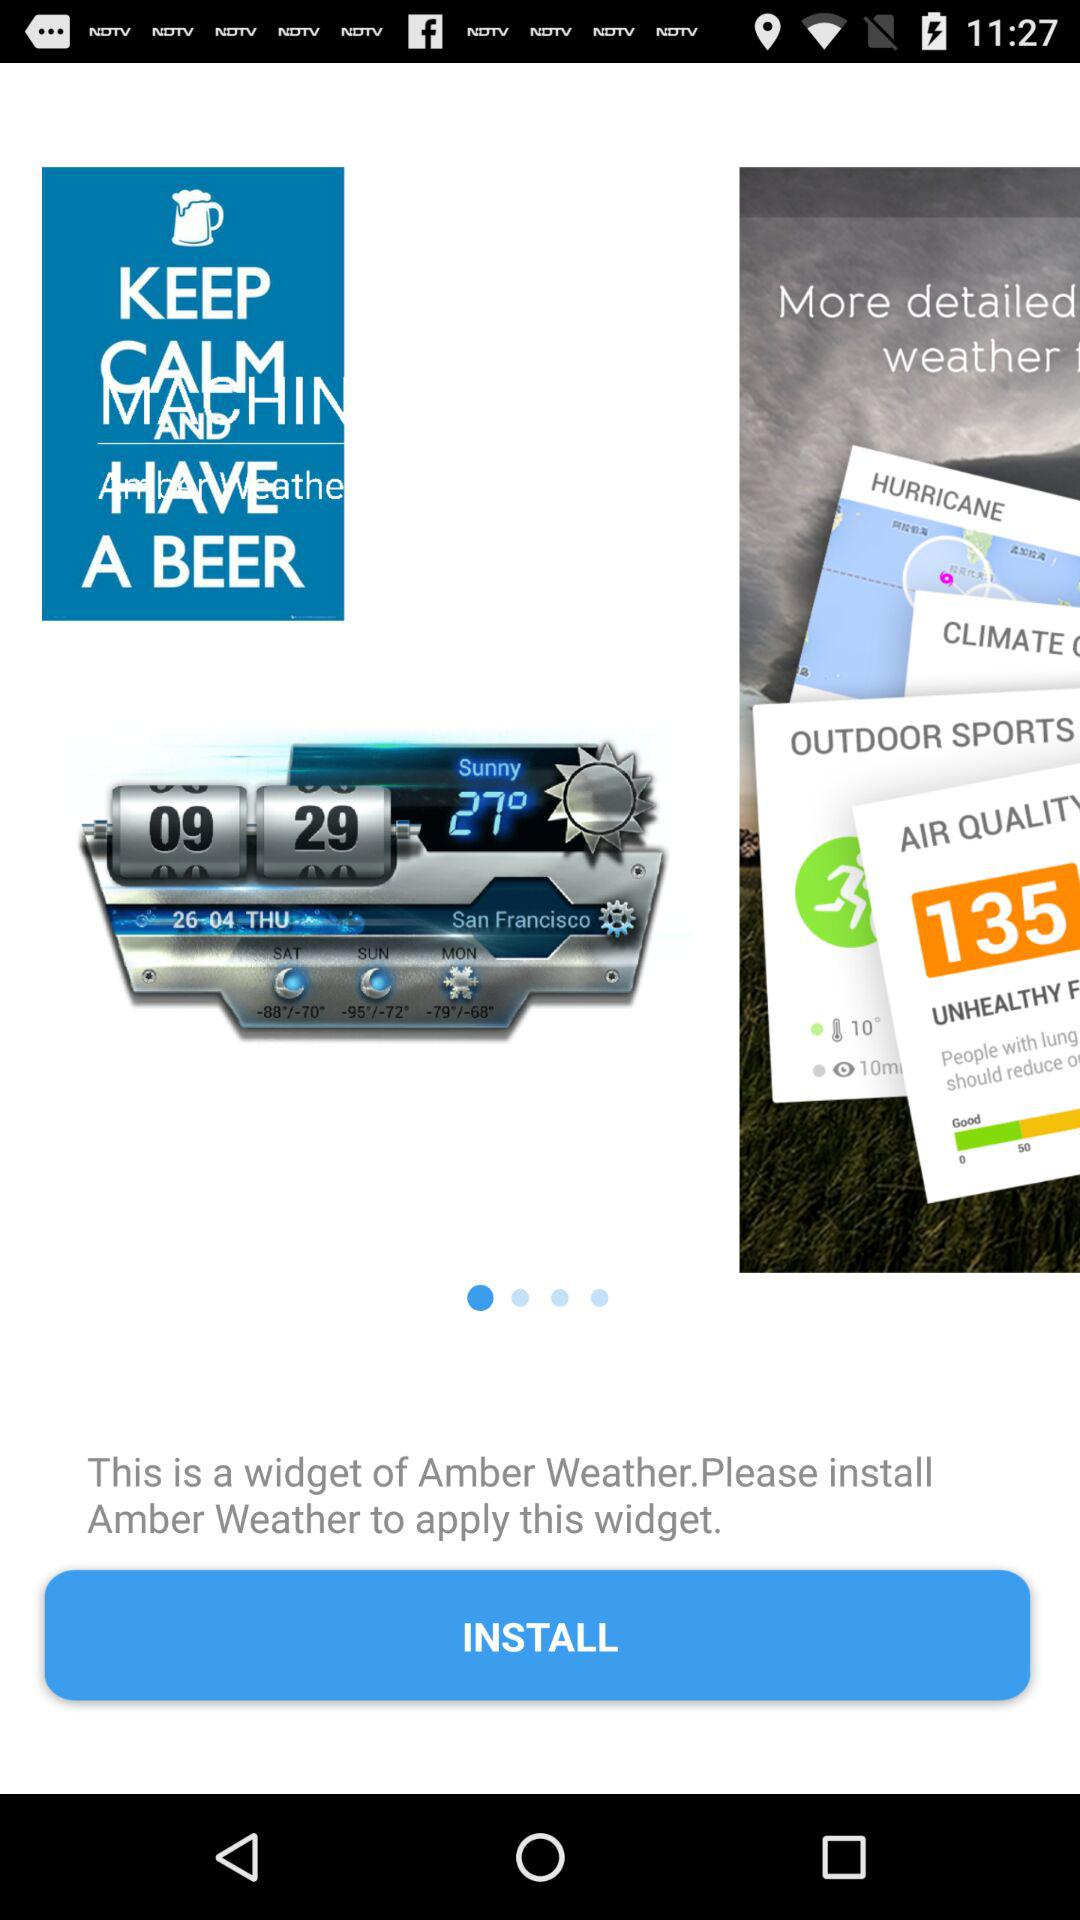What is the time in San Francisco? The time is 09:29. 